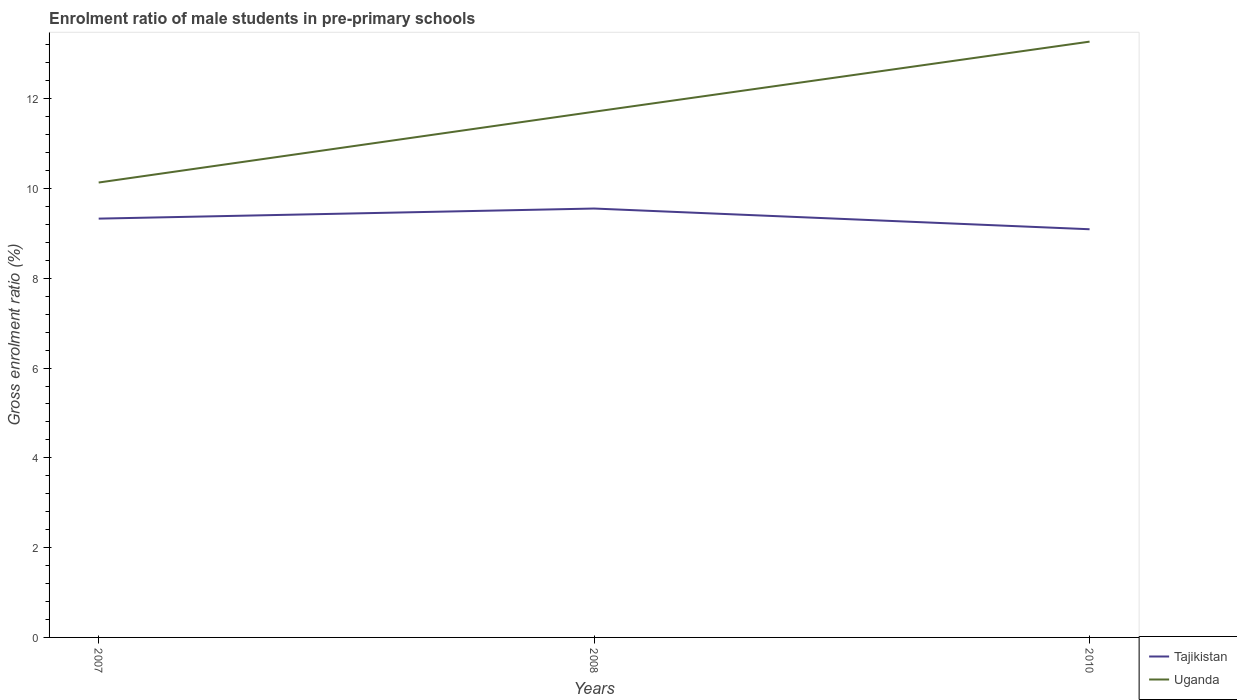How many different coloured lines are there?
Provide a short and direct response. 2. Does the line corresponding to Tajikistan intersect with the line corresponding to Uganda?
Keep it short and to the point. No. Is the number of lines equal to the number of legend labels?
Provide a short and direct response. Yes. Across all years, what is the maximum enrolment ratio of male students in pre-primary schools in Tajikistan?
Your answer should be compact. 9.09. In which year was the enrolment ratio of male students in pre-primary schools in Tajikistan maximum?
Make the answer very short. 2010. What is the total enrolment ratio of male students in pre-primary schools in Uganda in the graph?
Your answer should be very brief. -3.14. What is the difference between the highest and the second highest enrolment ratio of male students in pre-primary schools in Tajikistan?
Your answer should be compact. 0.46. What is the difference between the highest and the lowest enrolment ratio of male students in pre-primary schools in Uganda?
Your answer should be compact. 2. What is the difference between two consecutive major ticks on the Y-axis?
Keep it short and to the point. 2. Are the values on the major ticks of Y-axis written in scientific E-notation?
Provide a short and direct response. No. Does the graph contain any zero values?
Your answer should be very brief. No. Where does the legend appear in the graph?
Keep it short and to the point. Bottom right. What is the title of the graph?
Your response must be concise. Enrolment ratio of male students in pre-primary schools. What is the Gross enrolment ratio (%) of Tajikistan in 2007?
Give a very brief answer. 9.33. What is the Gross enrolment ratio (%) in Uganda in 2007?
Keep it short and to the point. 10.13. What is the Gross enrolment ratio (%) of Tajikistan in 2008?
Ensure brevity in your answer.  9.55. What is the Gross enrolment ratio (%) of Uganda in 2008?
Your answer should be very brief. 11.71. What is the Gross enrolment ratio (%) of Tajikistan in 2010?
Keep it short and to the point. 9.09. What is the Gross enrolment ratio (%) in Uganda in 2010?
Give a very brief answer. 13.27. Across all years, what is the maximum Gross enrolment ratio (%) of Tajikistan?
Provide a succinct answer. 9.55. Across all years, what is the maximum Gross enrolment ratio (%) of Uganda?
Keep it short and to the point. 13.27. Across all years, what is the minimum Gross enrolment ratio (%) of Tajikistan?
Provide a succinct answer. 9.09. Across all years, what is the minimum Gross enrolment ratio (%) of Uganda?
Your answer should be very brief. 10.13. What is the total Gross enrolment ratio (%) in Tajikistan in the graph?
Your answer should be compact. 27.98. What is the total Gross enrolment ratio (%) of Uganda in the graph?
Make the answer very short. 35.12. What is the difference between the Gross enrolment ratio (%) of Tajikistan in 2007 and that in 2008?
Provide a succinct answer. -0.22. What is the difference between the Gross enrolment ratio (%) in Uganda in 2007 and that in 2008?
Make the answer very short. -1.58. What is the difference between the Gross enrolment ratio (%) of Tajikistan in 2007 and that in 2010?
Offer a very short reply. 0.24. What is the difference between the Gross enrolment ratio (%) of Uganda in 2007 and that in 2010?
Keep it short and to the point. -3.14. What is the difference between the Gross enrolment ratio (%) of Tajikistan in 2008 and that in 2010?
Offer a terse response. 0.46. What is the difference between the Gross enrolment ratio (%) of Uganda in 2008 and that in 2010?
Offer a very short reply. -1.56. What is the difference between the Gross enrolment ratio (%) of Tajikistan in 2007 and the Gross enrolment ratio (%) of Uganda in 2008?
Provide a succinct answer. -2.38. What is the difference between the Gross enrolment ratio (%) in Tajikistan in 2007 and the Gross enrolment ratio (%) in Uganda in 2010?
Your response must be concise. -3.94. What is the difference between the Gross enrolment ratio (%) of Tajikistan in 2008 and the Gross enrolment ratio (%) of Uganda in 2010?
Provide a short and direct response. -3.72. What is the average Gross enrolment ratio (%) of Tajikistan per year?
Give a very brief answer. 9.33. What is the average Gross enrolment ratio (%) in Uganda per year?
Provide a short and direct response. 11.71. In the year 2007, what is the difference between the Gross enrolment ratio (%) of Tajikistan and Gross enrolment ratio (%) of Uganda?
Offer a very short reply. -0.8. In the year 2008, what is the difference between the Gross enrolment ratio (%) in Tajikistan and Gross enrolment ratio (%) in Uganda?
Give a very brief answer. -2.16. In the year 2010, what is the difference between the Gross enrolment ratio (%) of Tajikistan and Gross enrolment ratio (%) of Uganda?
Your answer should be compact. -4.18. What is the ratio of the Gross enrolment ratio (%) in Tajikistan in 2007 to that in 2008?
Offer a terse response. 0.98. What is the ratio of the Gross enrolment ratio (%) of Uganda in 2007 to that in 2008?
Offer a terse response. 0.87. What is the ratio of the Gross enrolment ratio (%) in Tajikistan in 2007 to that in 2010?
Provide a short and direct response. 1.03. What is the ratio of the Gross enrolment ratio (%) of Uganda in 2007 to that in 2010?
Give a very brief answer. 0.76. What is the ratio of the Gross enrolment ratio (%) in Tajikistan in 2008 to that in 2010?
Offer a very short reply. 1.05. What is the ratio of the Gross enrolment ratio (%) in Uganda in 2008 to that in 2010?
Give a very brief answer. 0.88. What is the difference between the highest and the second highest Gross enrolment ratio (%) in Tajikistan?
Ensure brevity in your answer.  0.22. What is the difference between the highest and the second highest Gross enrolment ratio (%) in Uganda?
Ensure brevity in your answer.  1.56. What is the difference between the highest and the lowest Gross enrolment ratio (%) of Tajikistan?
Your answer should be very brief. 0.46. What is the difference between the highest and the lowest Gross enrolment ratio (%) in Uganda?
Make the answer very short. 3.14. 